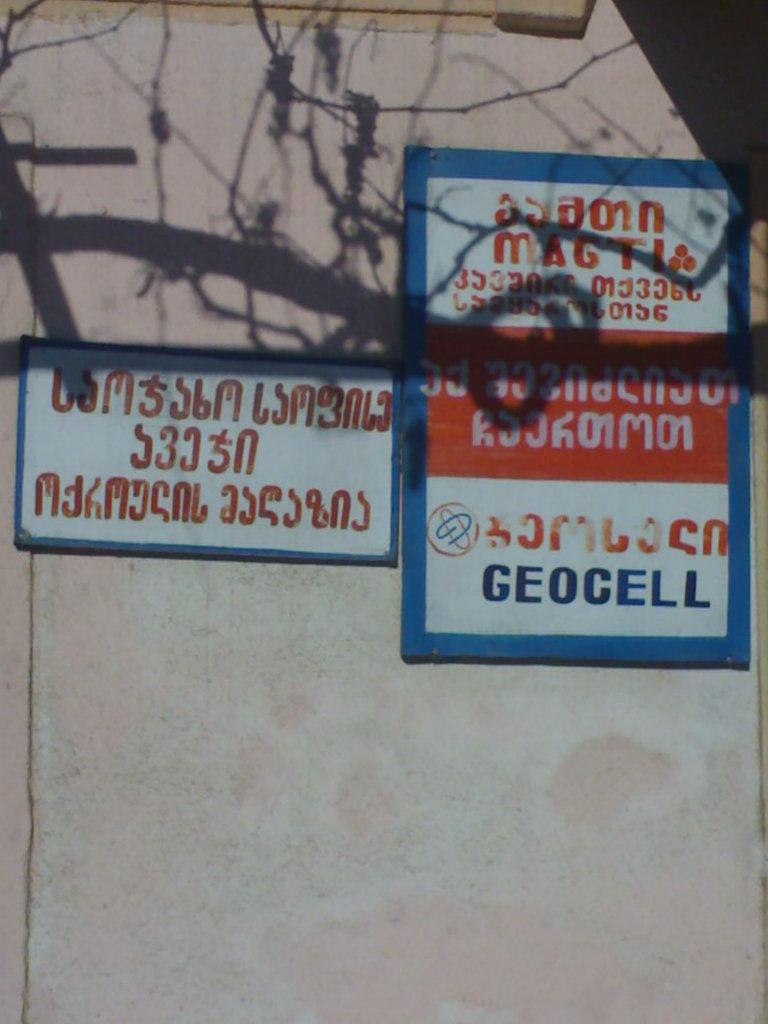<image>
Relay a brief, clear account of the picture shown. The service advertised in the poster is supported by Geocell. 